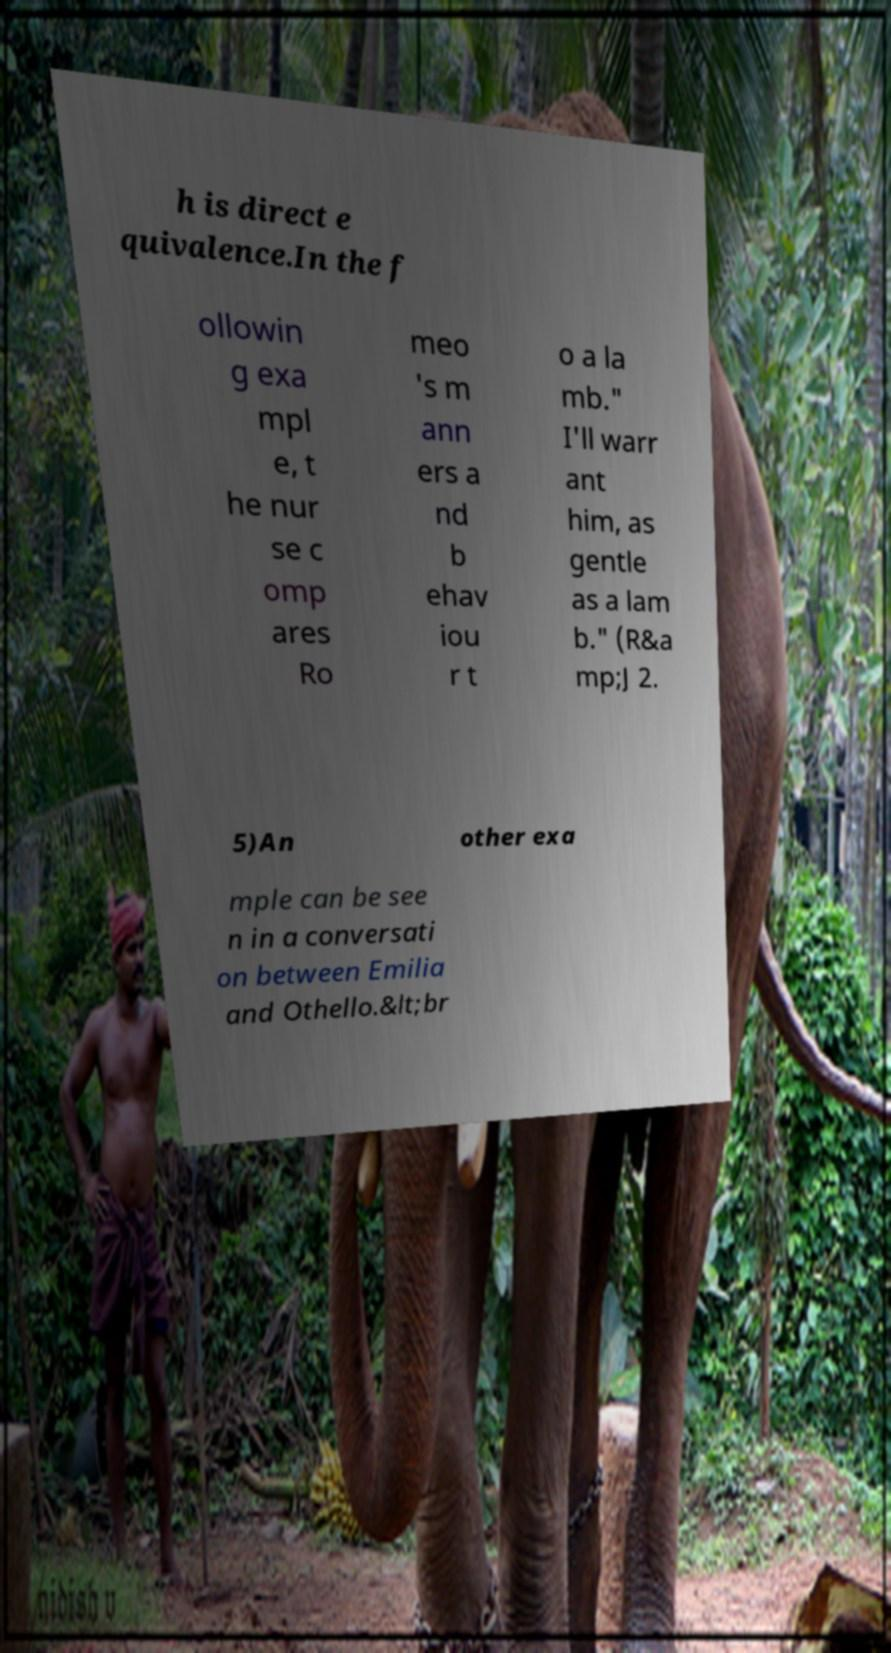Could you extract and type out the text from this image? h is direct e quivalence.In the f ollowin g exa mpl e, t he nur se c omp ares Ro meo 's m ann ers a nd b ehav iou r t o a la mb." I'll warr ant him, as gentle as a lam b." (R&a mp;J 2. 5)An other exa mple can be see n in a conversati on between Emilia and Othello.&lt;br 